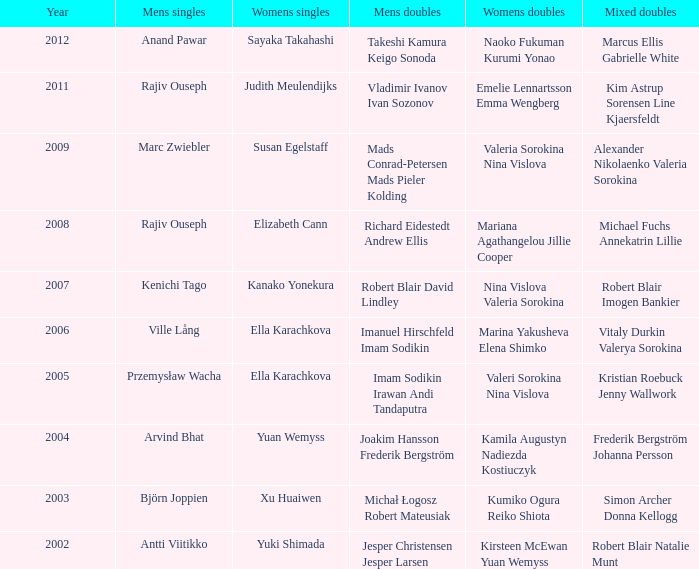In the context of marcus ellis and gabrielle white, what is the women's singles event? Sayaka Takahashi. 